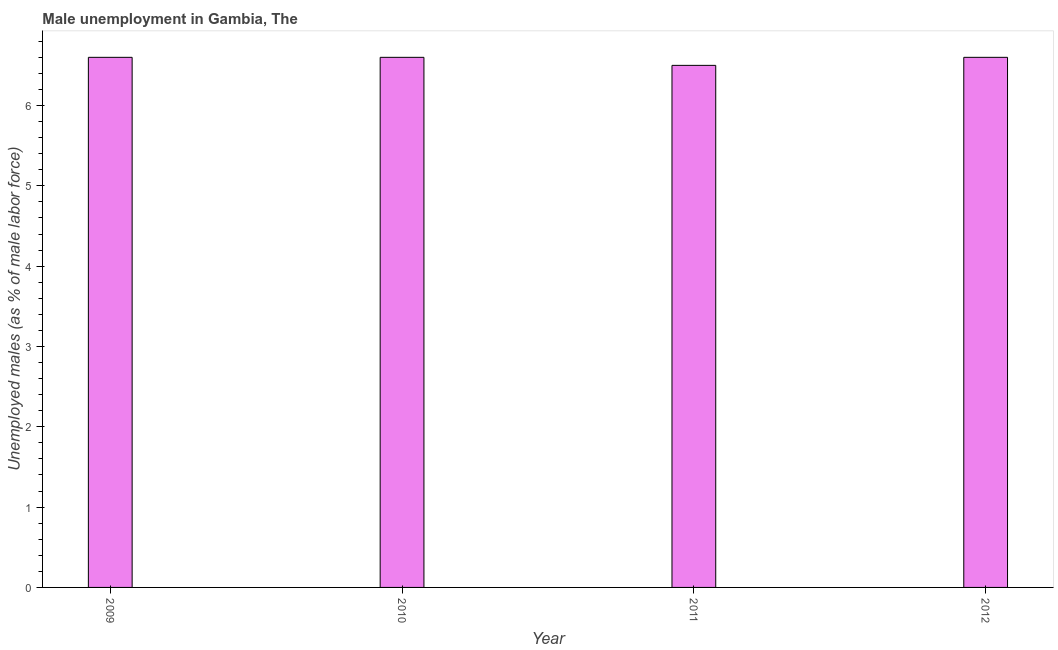What is the title of the graph?
Provide a short and direct response. Male unemployment in Gambia, The. What is the label or title of the Y-axis?
Make the answer very short. Unemployed males (as % of male labor force). Across all years, what is the maximum unemployed males population?
Provide a succinct answer. 6.6. Across all years, what is the minimum unemployed males population?
Offer a very short reply. 6.5. What is the sum of the unemployed males population?
Offer a terse response. 26.3. What is the average unemployed males population per year?
Your response must be concise. 6.58. What is the median unemployed males population?
Offer a terse response. 6.6. Do a majority of the years between 2009 and 2012 (inclusive) have unemployed males population greater than 5.2 %?
Your answer should be very brief. Yes. What is the difference between the highest and the second highest unemployed males population?
Keep it short and to the point. 0. What is the difference between the highest and the lowest unemployed males population?
Your response must be concise. 0.1. How many bars are there?
Your response must be concise. 4. Are all the bars in the graph horizontal?
Your response must be concise. No. What is the difference between two consecutive major ticks on the Y-axis?
Ensure brevity in your answer.  1. Are the values on the major ticks of Y-axis written in scientific E-notation?
Keep it short and to the point. No. What is the Unemployed males (as % of male labor force) of 2009?
Give a very brief answer. 6.6. What is the Unemployed males (as % of male labor force) of 2010?
Provide a succinct answer. 6.6. What is the Unemployed males (as % of male labor force) in 2011?
Your answer should be compact. 6.5. What is the Unemployed males (as % of male labor force) in 2012?
Your response must be concise. 6.6. What is the difference between the Unemployed males (as % of male labor force) in 2009 and 2011?
Your response must be concise. 0.1. What is the difference between the Unemployed males (as % of male labor force) in 2009 and 2012?
Keep it short and to the point. 0. What is the difference between the Unemployed males (as % of male labor force) in 2010 and 2011?
Ensure brevity in your answer.  0.1. What is the difference between the Unemployed males (as % of male labor force) in 2010 and 2012?
Ensure brevity in your answer.  0. What is the difference between the Unemployed males (as % of male labor force) in 2011 and 2012?
Offer a terse response. -0.1. What is the ratio of the Unemployed males (as % of male labor force) in 2009 to that in 2011?
Provide a succinct answer. 1.01. What is the ratio of the Unemployed males (as % of male labor force) in 2009 to that in 2012?
Make the answer very short. 1. What is the ratio of the Unemployed males (as % of male labor force) in 2011 to that in 2012?
Make the answer very short. 0.98. 